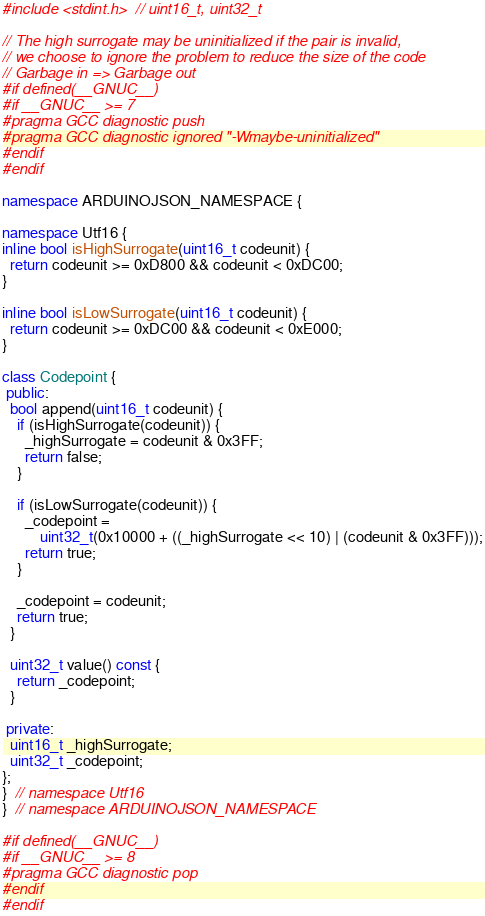Convert code to text. <code><loc_0><loc_0><loc_500><loc_500><_C++_>
#include <stdint.h>  // uint16_t, uint32_t

// The high surrogate may be uninitialized if the pair is invalid,
// we choose to ignore the problem to reduce the size of the code
// Garbage in => Garbage out
#if defined(__GNUC__)
#if __GNUC__ >= 7
#pragma GCC diagnostic push
#pragma GCC diagnostic ignored "-Wmaybe-uninitialized"
#endif
#endif

namespace ARDUINOJSON_NAMESPACE {

namespace Utf16 {
inline bool isHighSurrogate(uint16_t codeunit) {
  return codeunit >= 0xD800 && codeunit < 0xDC00;
}

inline bool isLowSurrogate(uint16_t codeunit) {
  return codeunit >= 0xDC00 && codeunit < 0xE000;
}

class Codepoint {
 public:
  bool append(uint16_t codeunit) {
    if (isHighSurrogate(codeunit)) {
      _highSurrogate = codeunit & 0x3FF;
      return false;
    }

    if (isLowSurrogate(codeunit)) {
      _codepoint =
          uint32_t(0x10000 + ((_highSurrogate << 10) | (codeunit & 0x3FF)));
      return true;
    }

    _codepoint = codeunit;
    return true;
  }

  uint32_t value() const {
    return _codepoint;
  }

 private:
  uint16_t _highSurrogate;
  uint32_t _codepoint;
};
}  // namespace Utf16
}  // namespace ARDUINOJSON_NAMESPACE

#if defined(__GNUC__)
#if __GNUC__ >= 8
#pragma GCC diagnostic pop
#endif
#endif
</code> 